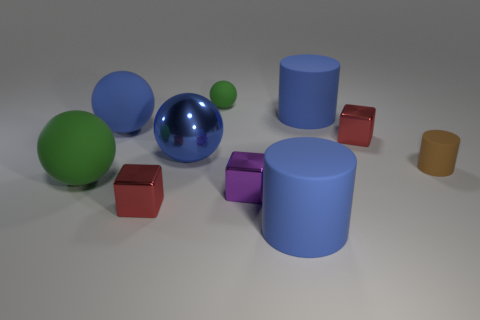Subtract 1 balls. How many balls are left? 3 Subtract all red balls. Subtract all red cubes. How many balls are left? 4 Add 2 metal objects. How many metal objects exist? 6 Subtract 0 red spheres. How many objects are left? 10 Subtract all cylinders. How many objects are left? 7 Subtract all large cyan metal spheres. Subtract all small red things. How many objects are left? 8 Add 1 big matte spheres. How many big matte spheres are left? 3 